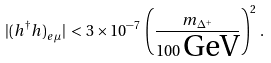<formula> <loc_0><loc_0><loc_500><loc_500>| ( h ^ { \dagger } h ) _ { e \mu } | \, < \, 3 \times 1 0 ^ { - 7 } \, \left ( \frac { m _ { \Delta ^ { + } } } { 1 0 0 \, \text {GeV} } \right ) ^ { 2 } \, .</formula> 